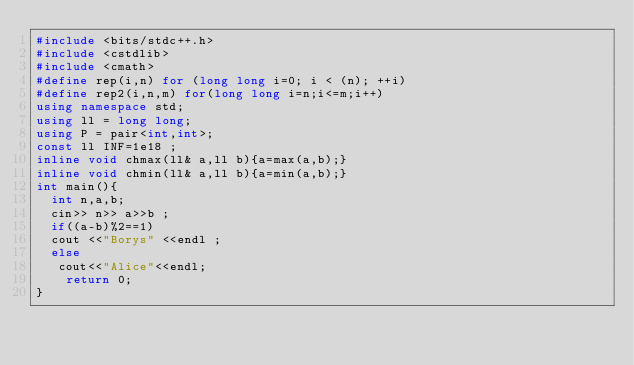<code> <loc_0><loc_0><loc_500><loc_500><_C++_>#include <bits/stdc++.h>
#include <cstdlib>
#include <cmath>
#define rep(i,n) for (long long i=0; i < (n); ++i)
#define rep2(i,n,m) for(long long i=n;i<=m;i++)
using namespace std;
using ll = long long;
using P = pair<int,int>;
const ll INF=1e18 ;
inline void chmax(ll& a,ll b){a=max(a,b);}
inline void chmin(ll& a,ll b){a=min(a,b);}
int main(){
  int n,a,b;
  cin>> n>> a>>b ;
  if((a-b)%2==1)
  cout <<"Borys" <<endl ;
  else
   cout<<"Alice"<<endl; 
    return 0;
}</code> 